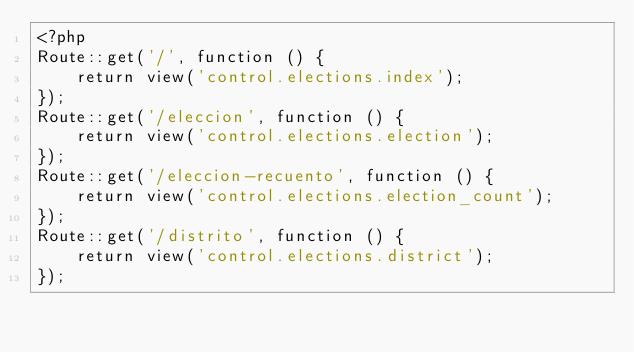Convert code to text. <code><loc_0><loc_0><loc_500><loc_500><_PHP_><?php
Route::get('/', function () {
    return view('control.elections.index');
});
Route::get('/eleccion', function () {
    return view('control.elections.election');
});
Route::get('/eleccion-recuento', function () {
    return view('control.elections.election_count');
});
Route::get('/distrito', function () {
    return view('control.elections.district');
});</code> 